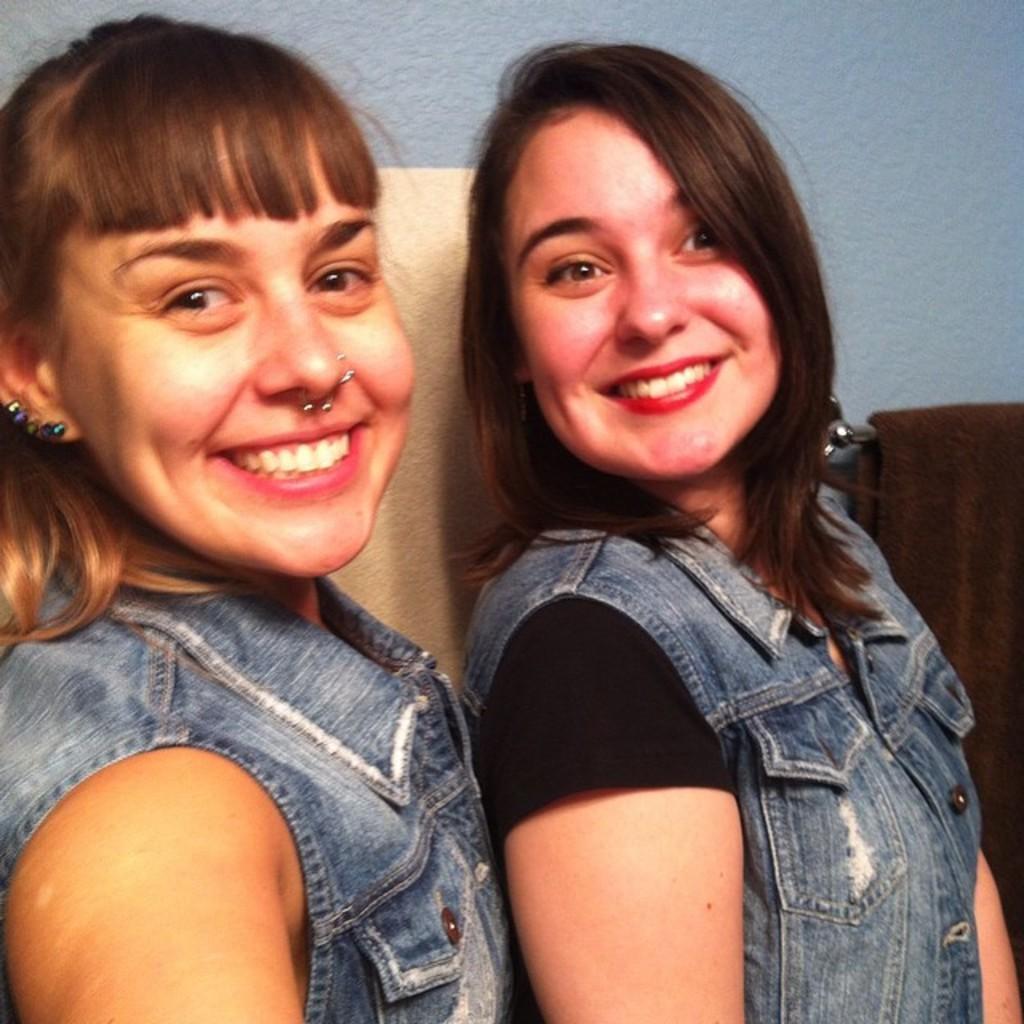Please provide a concise description of this image. In this image we can see two persons. Behind the persons there is a cloth and a wall. On the right side there is a cloth hanged on a metal. 